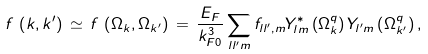Convert formula to latex. <formula><loc_0><loc_0><loc_500><loc_500>f \, \left ( k , k ^ { \prime } \right ) \, \simeq \, f \, \left ( \Omega _ { k } , \Omega _ { k ^ { \prime } } \right ) \, = \, \frac { E _ { F } } { k _ { F 0 } ^ { 3 } } \sum _ { l l ^ { \prime } m } f _ { l l ^ { \prime } , m } Y _ { l m } ^ { \ast } \left ( \Omega _ { k } ^ { q } \right ) Y _ { l ^ { \prime } m } \left ( \Omega _ { k ^ { \prime } } ^ { q } \right ) ,</formula> 